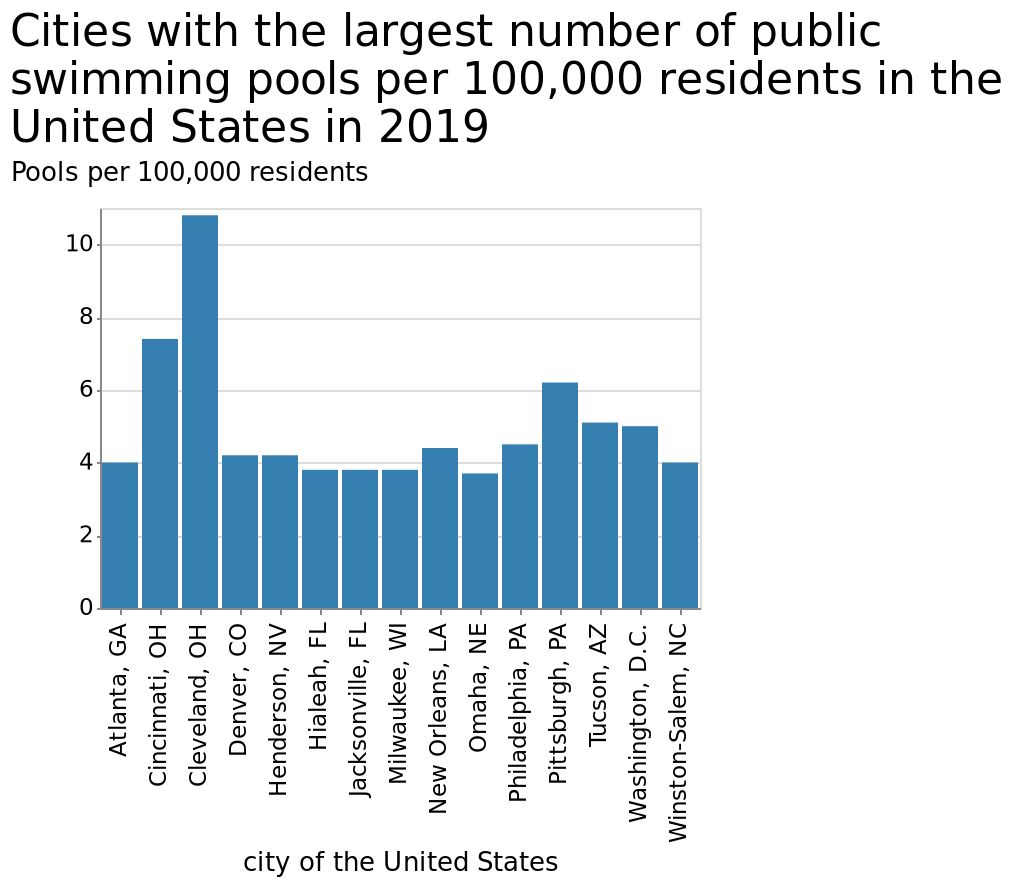<image>
Offer a thorough analysis of the image. Cleveland, OH has the highest number of pools per 100,000 residents by far. Omaha, NE has the least number of pools per 100,000 residents, closely followed by Hialeah, Jacksonville and Milwaukee, who all have the same number of pools per 100,000 residents. 